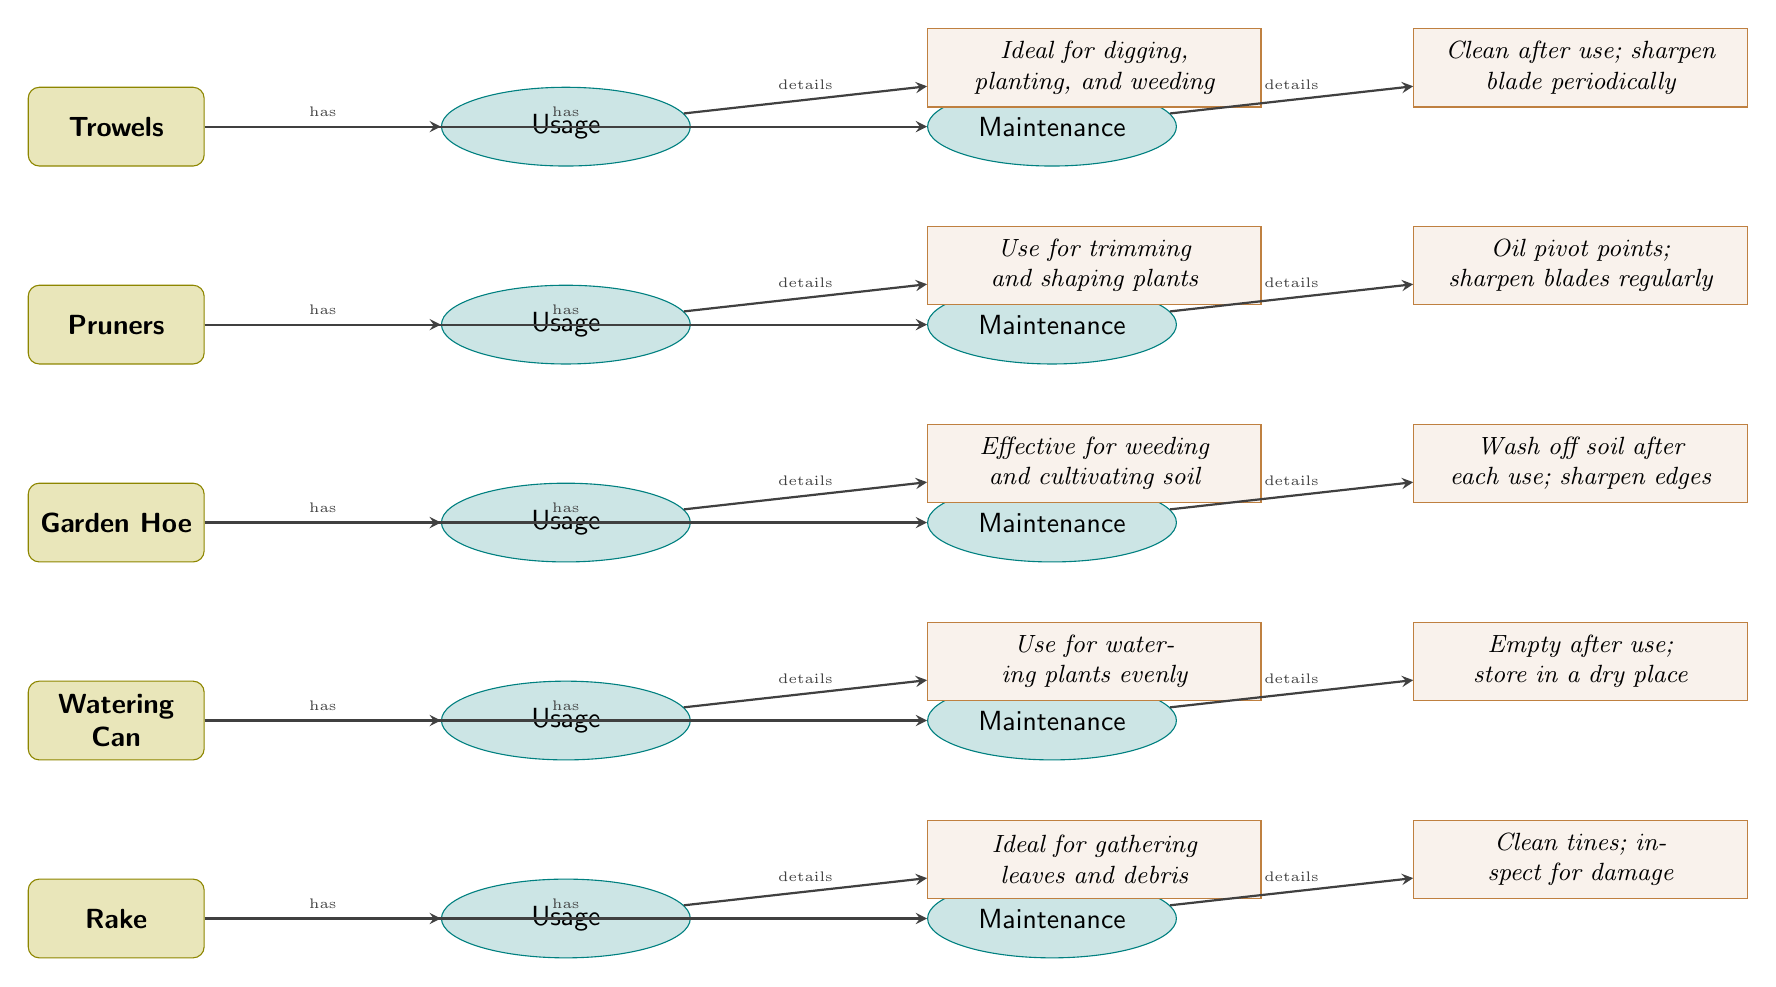What tool is used for digging, planting, and weeding? The diagram indicates that Trowels are ideal for digging, planting, and weeding, as stated in the description connected to the usage category of Trowels.
Answer: Trowels How many tools are listed in the diagram? There are five tools displayed in the diagram: Trowels, Pruners, Garden Hoe, Watering Can, and Rake. We simply count each unique tool represented in the diagram.
Answer: 5 What maintenance action is suggested for pruners? The description linked to the maintenance category of Pruners suggests that oiling pivot points is necessary, along with sharpening blades regularly. This describes the specific action required for maintaining pruners.
Answer: Oil pivot points; sharpen blades regularly Which tool is associated with watering plants evenly? The diagram specifies that the Watering Can is used for watering plants evenly, as described in the usage section related to the Watering Can.
Answer: Watering Can What is the primary usage of a garden hoe? The description for the usage of a Garden Hoe states that it is effective for weeding and cultivating soil. By referring to the usage description next to the Garden Hoe, we can ascertain its primary function.
Answer: Weeding and cultivating soil Which maintenance task is advised after using a rake? The diagram shows that after using a rake, one should clean the tines and inspect for damage as part of the maintenance steps. This information can be found in the maintenance description associated with the Rake.
Answer: Clean tines; inspect for damage What two tools require sharpening as part of their maintenance? By reviewing the maintenance descriptions, Pruners and Trowels both require sharpening as part of their maintenance. The answer combines information from the maintenance sections of each tool and identifies those that necessitate sharpening.
Answer: Pruners and Trowels What category follows the Garden Hoe in the diagram? The next category after the Garden Hoe is its Maintenance category. This follows a sequential order found in the diagram where each tool is linked to its respective usage and maintenance categories.
Answer: Maintenance What does the watering can need after use? The maintenance description for the Watering Can states that it should be emptied after use. This can be found in the maintenance instructions specifically represented for the Watering Can.
Answer: Empty after use How is the relationship between tools and their usage described? The relationship is explicitly indicated by arrows leading from each tool to its corresponding usage category, labeled with "has." This shows the direct connection between each tool and its designated use outlined in the diagram.
Answer: Arrows indicating "has" relationship 